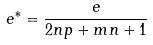<formula> <loc_0><loc_0><loc_500><loc_500>e ^ { * } = \frac { e } { 2 n p + m n + 1 }</formula> 